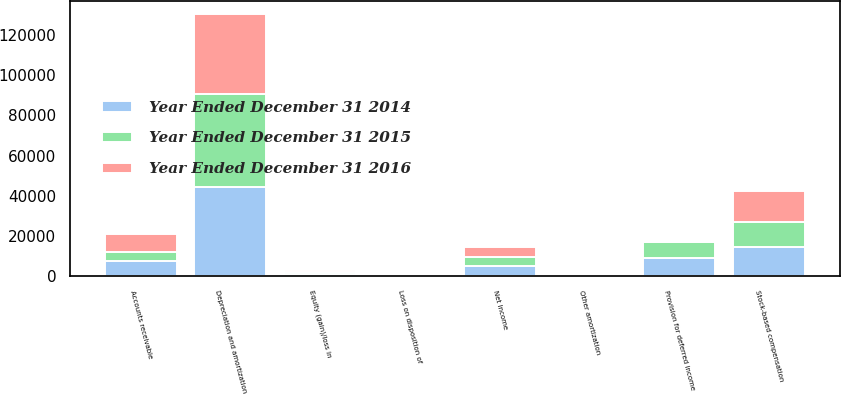<chart> <loc_0><loc_0><loc_500><loc_500><stacked_bar_chart><ecel><fcel>Net Income<fcel>Depreciation and amortization<fcel>Other amortization<fcel>Provision for deferred income<fcel>Stock-based compensation<fcel>Loss on disposition of<fcel>Equity (gain)/loss in<fcel>Accounts receivable<nl><fcel>Year Ended December 31 2014<fcel>4847<fcel>44377<fcel>78<fcel>8845<fcel>14503<fcel>9<fcel>1167<fcel>7367<nl><fcel>Year Ended December 31 2015<fcel>4847<fcel>46274<fcel>81<fcel>8282<fcel>12181<fcel>617<fcel>811<fcel>4847<nl><fcel>Year Ended December 31 2016<fcel>4847<fcel>39913<fcel>87<fcel>290<fcel>15577<fcel>662<fcel>1217<fcel>8498<nl></chart> 